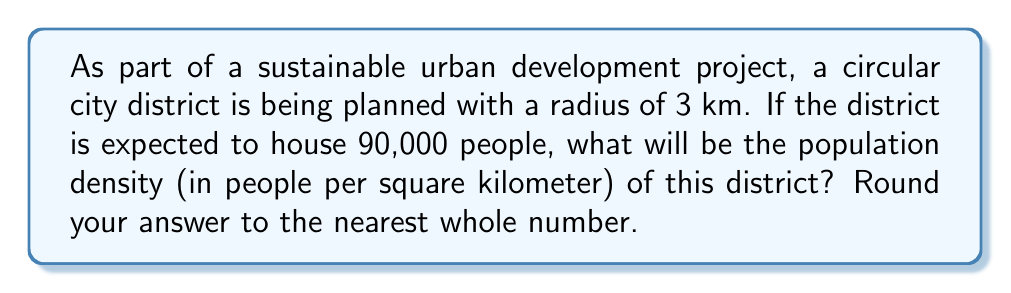Teach me how to tackle this problem. To solve this problem, we need to follow these steps:

1. Calculate the area of the circular district:
   The formula for the area of a circle is $A = \pi r^2$
   where $r$ is the radius.

   $A = \pi \cdot (3\text{ km})^2 = 9\pi \text{ km}^2$

2. Calculate the population density:
   Population density is defined as the number of people divided by the area.

   Density $= \frac{\text{Population}}{\text{Area}}$

   $= \frac{90,000}{9\pi \text{ km}^2}$

   $= \frac{10,000}{\pi} \text{ people/km}^2$

3. Evaluate and round to the nearest whole number:
   $\frac{10,000}{\pi} \approx 3183.10\ldots \text{ people/km}^2$

   Rounding to the nearest whole number: 3183 people/km²

This population density calculation is crucial for sustainable urban planning, as it helps determine the infrastructure and resources needed to support the population while minimizing environmental impact.
Answer: 3183 people/km² 